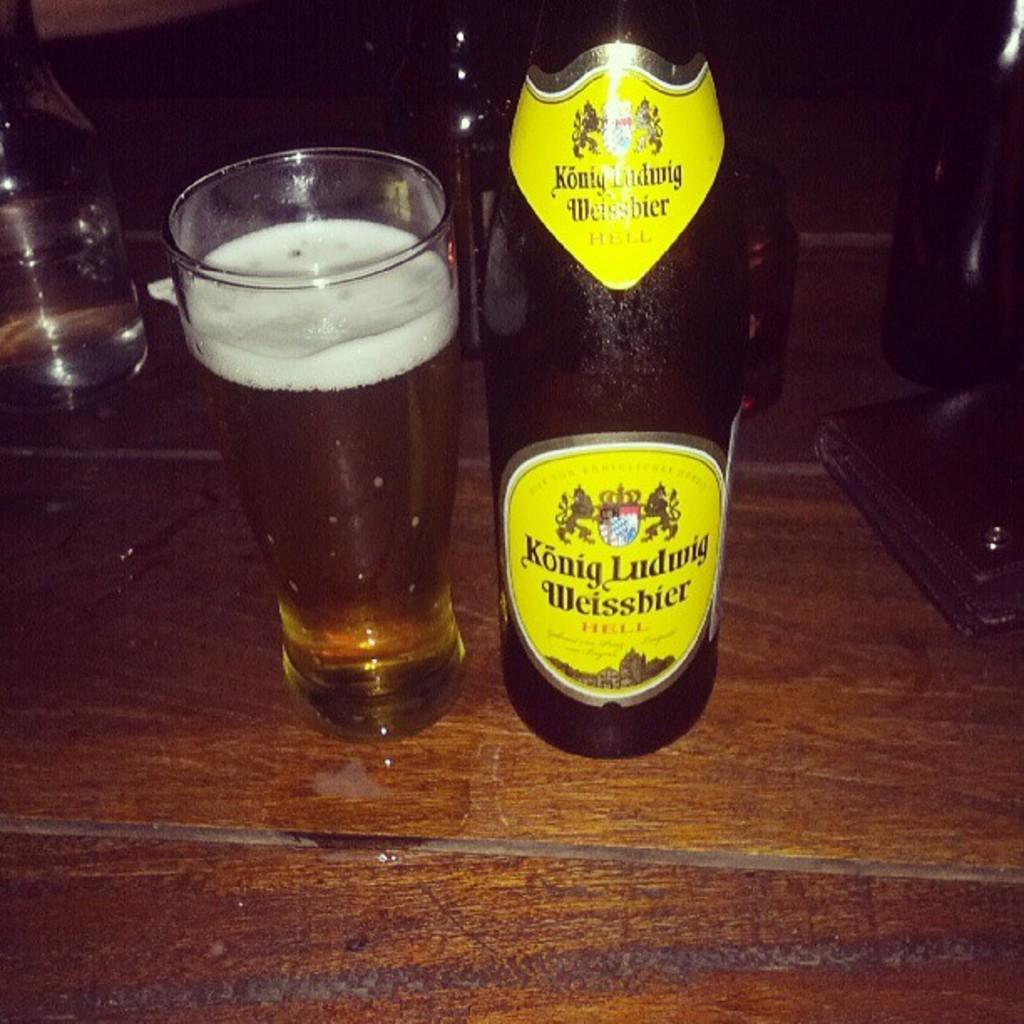<image>
Write a terse but informative summary of the picture. An empty bottle of Konig Ludwig Weissbier next to a full beer glass. 